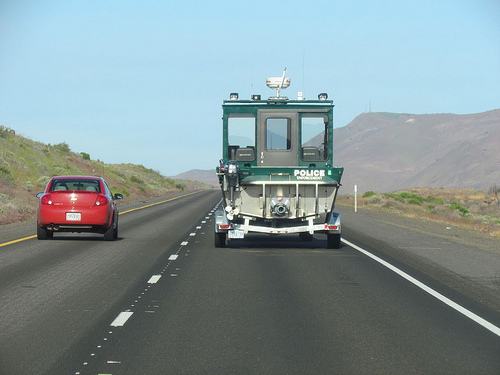<image>
Is the car to the left of the police van? Yes. From this viewpoint, the car is positioned to the left side relative to the police van. 